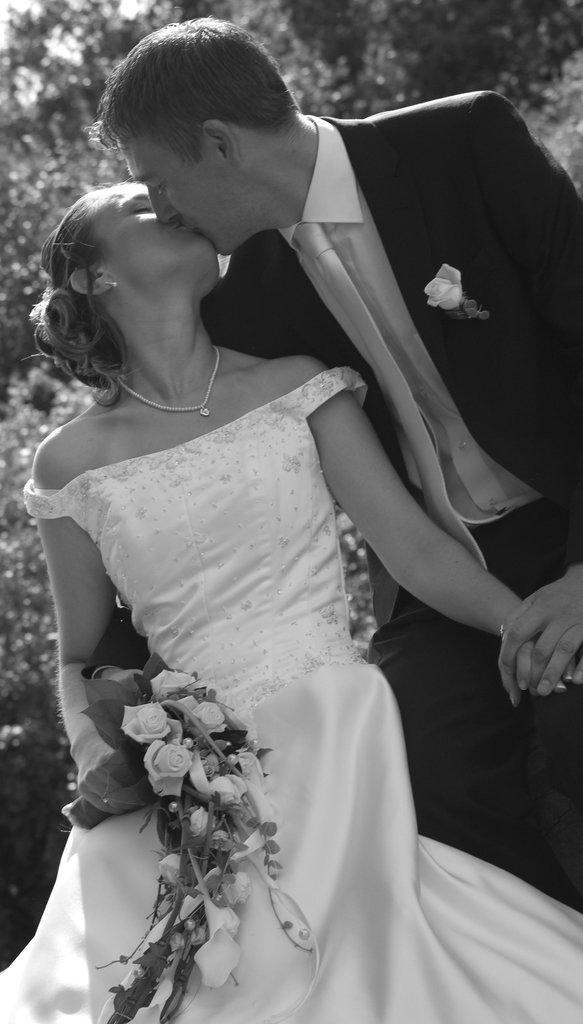Please provide a concise description of this image. This is a black and white image. In this image there is a man and a woman. Woman is holding a flower bouquet. In the background there are trees. 